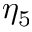Convert formula to latex. <formula><loc_0><loc_0><loc_500><loc_500>\eta _ { 5 }</formula> 